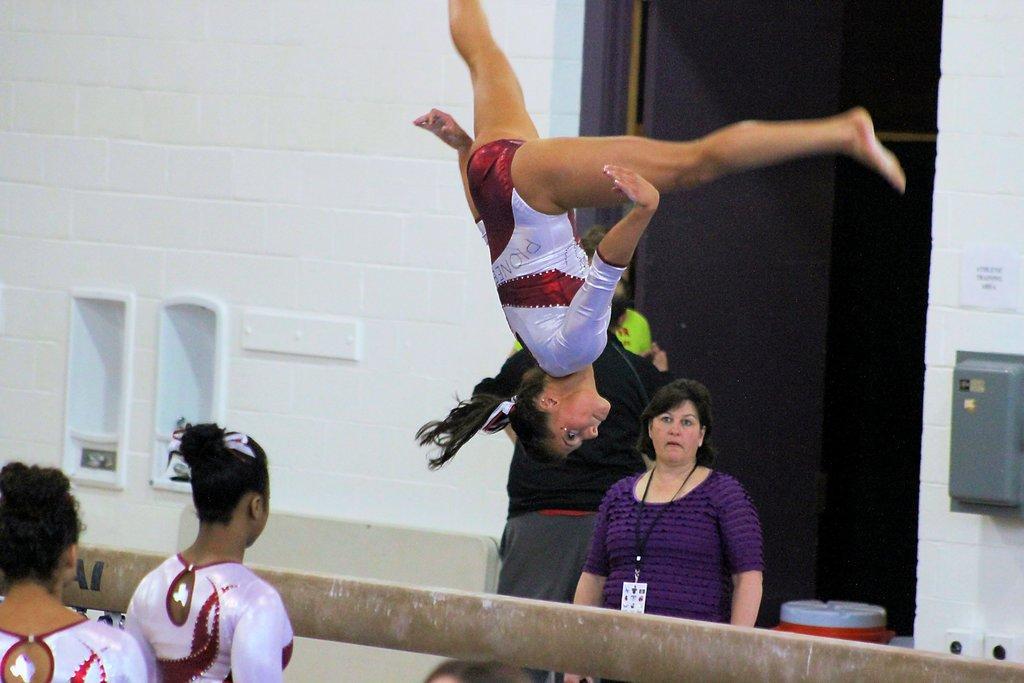Can you describe this image briefly? In this picture, we see the girl performing the acrobatics. At the bottom, we see two girls are standing. In front of them, we see a rod. Beside that, we see three people are standing. Behind them, we see a brown door. Beside that, we see a white wall. On the right side, we see a grey color box. In the background, we see a stool in white and red color. 